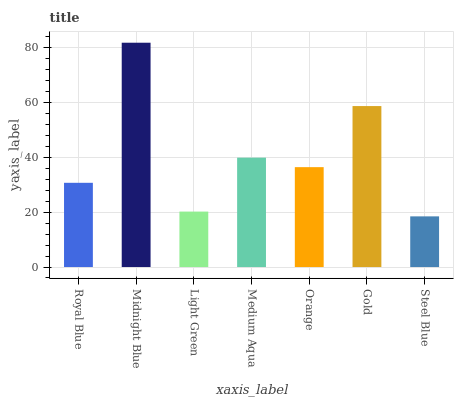Is Light Green the minimum?
Answer yes or no. No. Is Light Green the maximum?
Answer yes or no. No. Is Midnight Blue greater than Light Green?
Answer yes or no. Yes. Is Light Green less than Midnight Blue?
Answer yes or no. Yes. Is Light Green greater than Midnight Blue?
Answer yes or no. No. Is Midnight Blue less than Light Green?
Answer yes or no. No. Is Orange the high median?
Answer yes or no. Yes. Is Orange the low median?
Answer yes or no. Yes. Is Midnight Blue the high median?
Answer yes or no. No. Is Midnight Blue the low median?
Answer yes or no. No. 